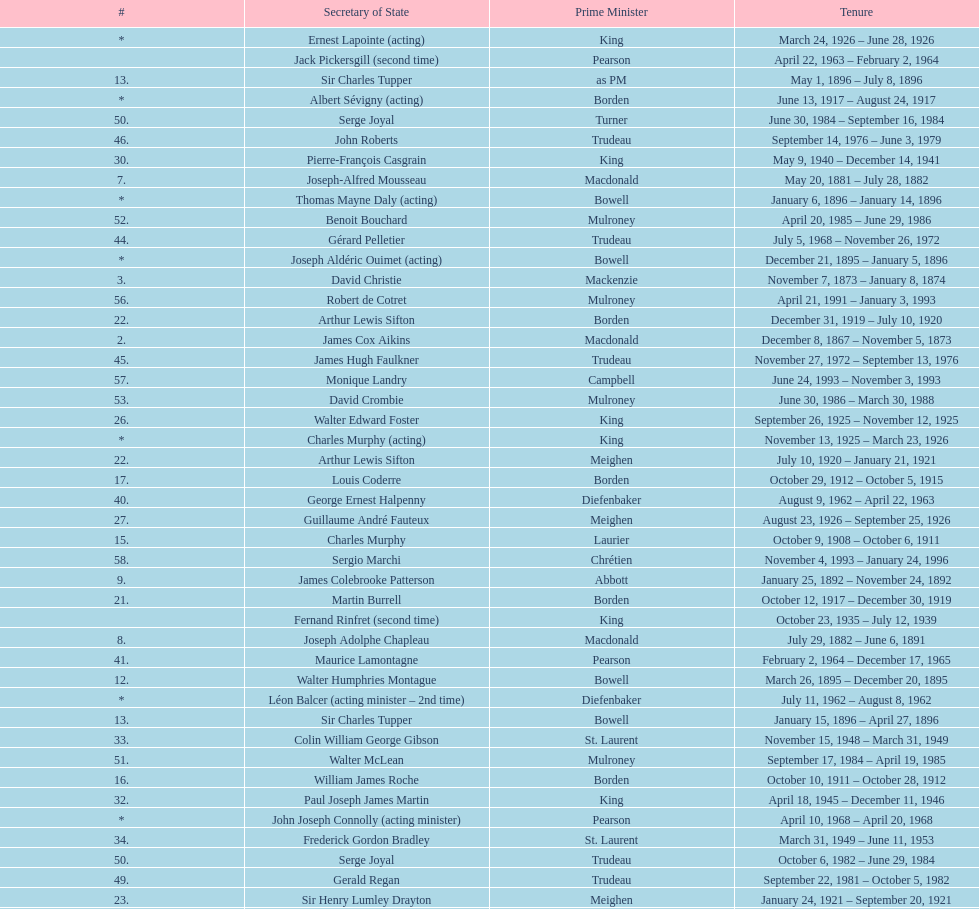How many secretary of states were under prime minister macdonald? 6. 